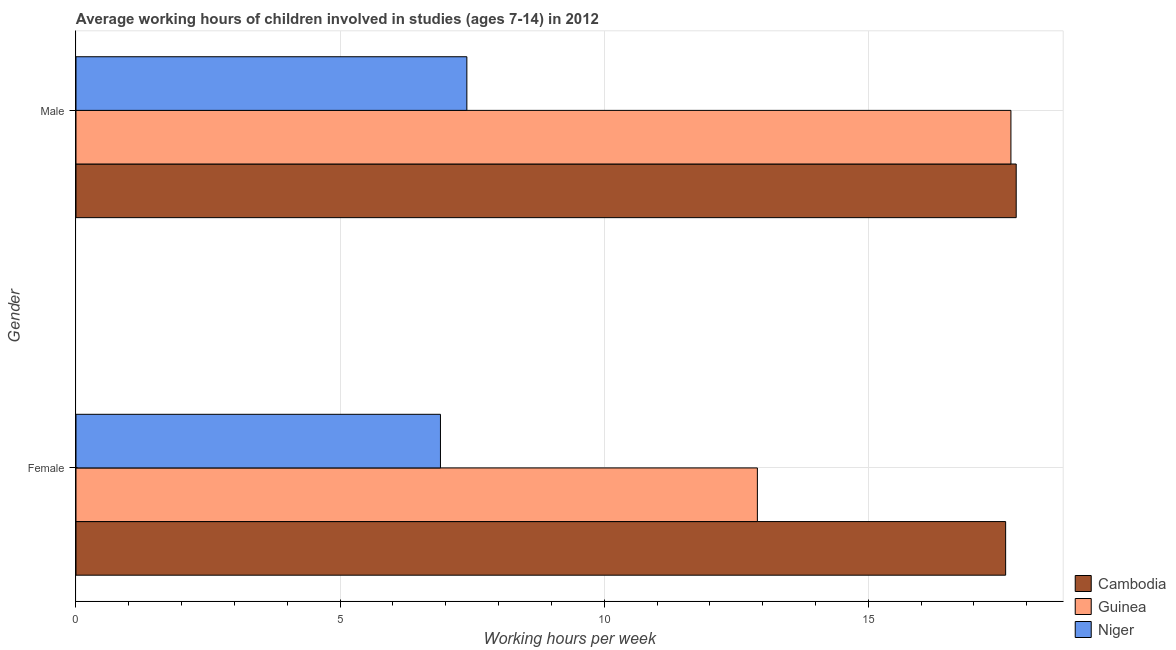How many different coloured bars are there?
Ensure brevity in your answer.  3. How many bars are there on the 2nd tick from the top?
Offer a very short reply. 3. What is the average working hour of male children in Cambodia?
Offer a very short reply. 17.8. Across all countries, what is the minimum average working hour of male children?
Offer a terse response. 7.4. In which country was the average working hour of male children maximum?
Make the answer very short. Cambodia. In which country was the average working hour of female children minimum?
Provide a short and direct response. Niger. What is the total average working hour of male children in the graph?
Keep it short and to the point. 42.9. What is the difference between the average working hour of male children in Guinea and that in Niger?
Keep it short and to the point. 10.3. What is the difference between the average working hour of female children in Niger and the average working hour of male children in Guinea?
Make the answer very short. -10.8. What is the average average working hour of male children per country?
Make the answer very short. 14.3. What is the difference between the average working hour of female children and average working hour of male children in Niger?
Your answer should be very brief. -0.5. What is the ratio of the average working hour of female children in Niger to that in Cambodia?
Ensure brevity in your answer.  0.39. What does the 2nd bar from the top in Male represents?
Ensure brevity in your answer.  Guinea. What does the 2nd bar from the bottom in Male represents?
Offer a terse response. Guinea. How many bars are there?
Offer a very short reply. 6. Are all the bars in the graph horizontal?
Give a very brief answer. Yes. How many countries are there in the graph?
Your response must be concise. 3. What is the difference between two consecutive major ticks on the X-axis?
Provide a succinct answer. 5. Does the graph contain any zero values?
Make the answer very short. No. Where does the legend appear in the graph?
Keep it short and to the point. Bottom right. How many legend labels are there?
Provide a succinct answer. 3. What is the title of the graph?
Your answer should be compact. Average working hours of children involved in studies (ages 7-14) in 2012. What is the label or title of the X-axis?
Your answer should be compact. Working hours per week. What is the Working hours per week of Cambodia in Female?
Give a very brief answer. 17.6. What is the Working hours per week of Niger in Male?
Offer a terse response. 7.4. Across all Gender, what is the maximum Working hours per week of Cambodia?
Provide a succinct answer. 17.8. Across all Gender, what is the maximum Working hours per week of Guinea?
Your response must be concise. 17.7. Across all Gender, what is the maximum Working hours per week in Niger?
Provide a short and direct response. 7.4. Across all Gender, what is the minimum Working hours per week in Cambodia?
Offer a very short reply. 17.6. Across all Gender, what is the minimum Working hours per week of Guinea?
Ensure brevity in your answer.  12.9. What is the total Working hours per week of Cambodia in the graph?
Offer a very short reply. 35.4. What is the total Working hours per week in Guinea in the graph?
Your answer should be compact. 30.6. What is the total Working hours per week in Niger in the graph?
Offer a terse response. 14.3. What is the difference between the Working hours per week in Niger in Female and that in Male?
Make the answer very short. -0.5. What is the difference between the Working hours per week in Cambodia in Female and the Working hours per week in Niger in Male?
Make the answer very short. 10.2. What is the average Working hours per week of Niger per Gender?
Make the answer very short. 7.15. What is the difference between the Working hours per week of Cambodia and Working hours per week of Guinea in Female?
Your answer should be compact. 4.7. What is the difference between the Working hours per week of Cambodia and Working hours per week of Niger in Female?
Your answer should be compact. 10.7. What is the difference between the Working hours per week in Guinea and Working hours per week in Niger in Female?
Offer a terse response. 6. What is the difference between the Working hours per week of Cambodia and Working hours per week of Guinea in Male?
Your answer should be very brief. 0.1. What is the ratio of the Working hours per week in Guinea in Female to that in Male?
Provide a short and direct response. 0.73. What is the ratio of the Working hours per week in Niger in Female to that in Male?
Offer a terse response. 0.93. What is the difference between the highest and the second highest Working hours per week in Cambodia?
Offer a very short reply. 0.2. What is the difference between the highest and the second highest Working hours per week in Guinea?
Your answer should be very brief. 4.8. What is the difference between the highest and the second highest Working hours per week of Niger?
Offer a very short reply. 0.5. What is the difference between the highest and the lowest Working hours per week of Guinea?
Provide a short and direct response. 4.8. What is the difference between the highest and the lowest Working hours per week in Niger?
Your answer should be very brief. 0.5. 